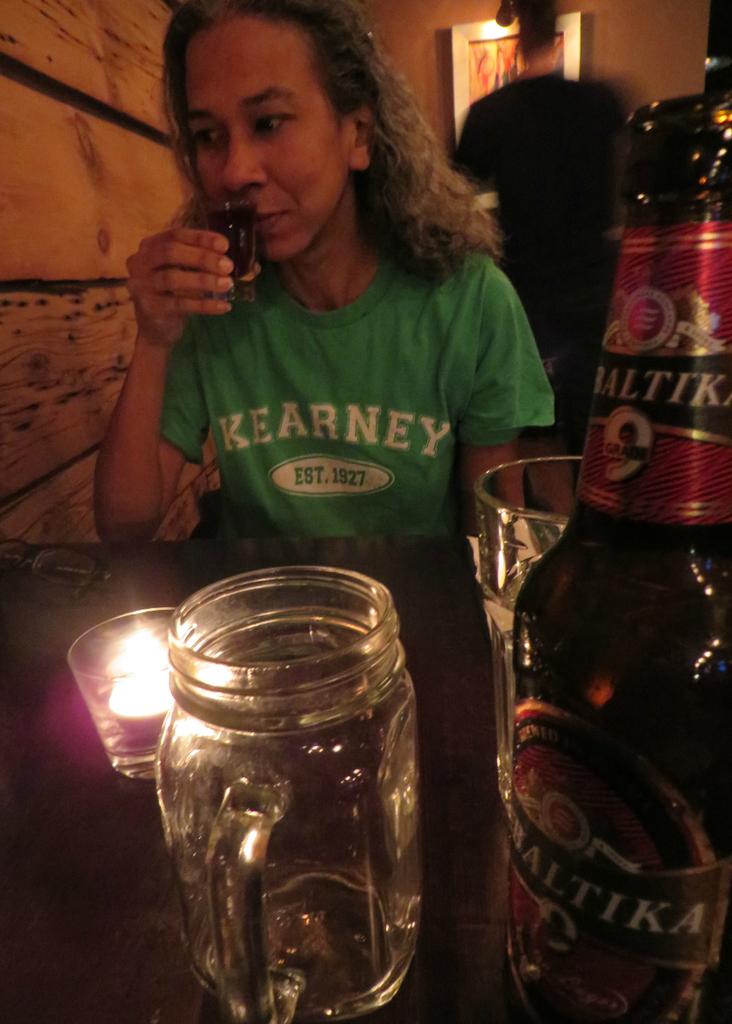What big white number is on the beer bottle?
Provide a succinct answer. 9. 